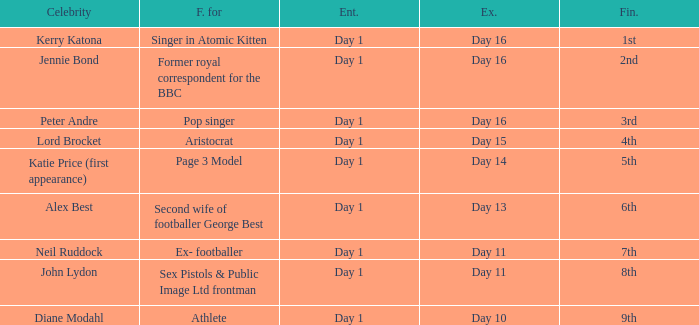Name the number of celebrity for athlete 1.0. 